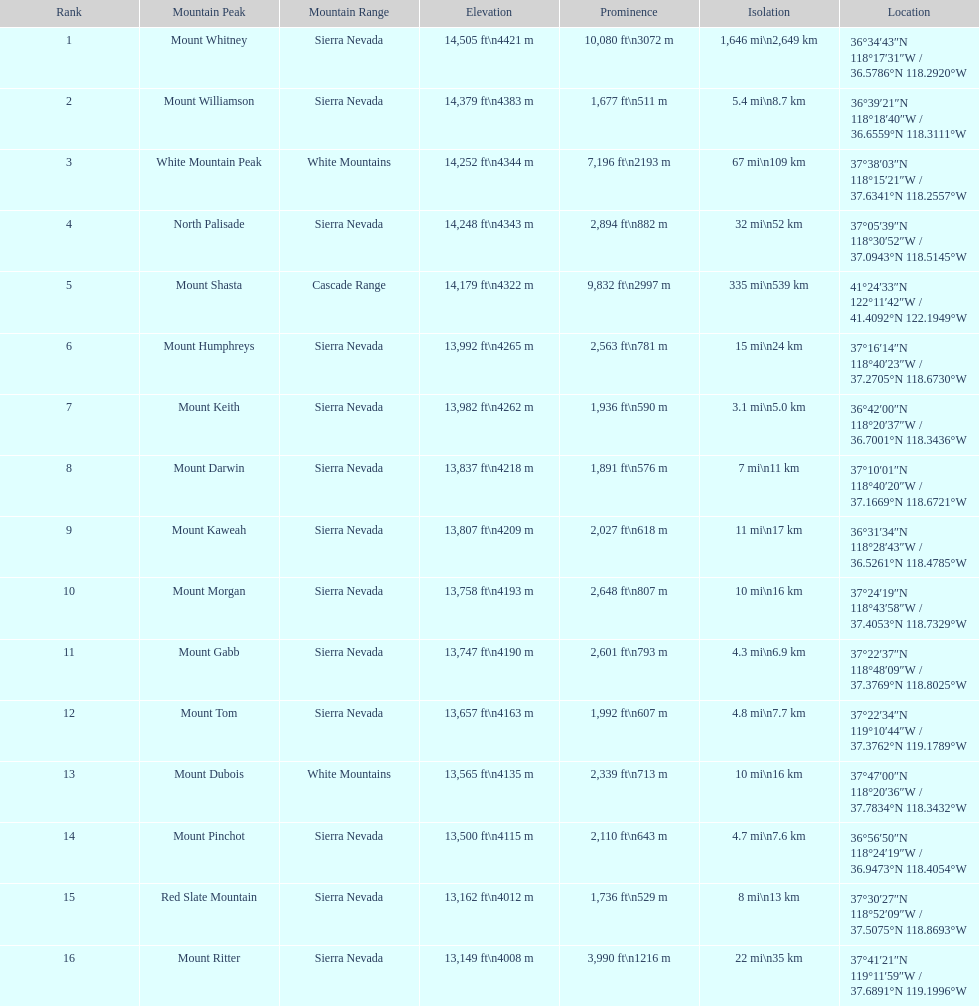Which is higher, mount humphreys or mount kaweah? Mount Humphreys. 